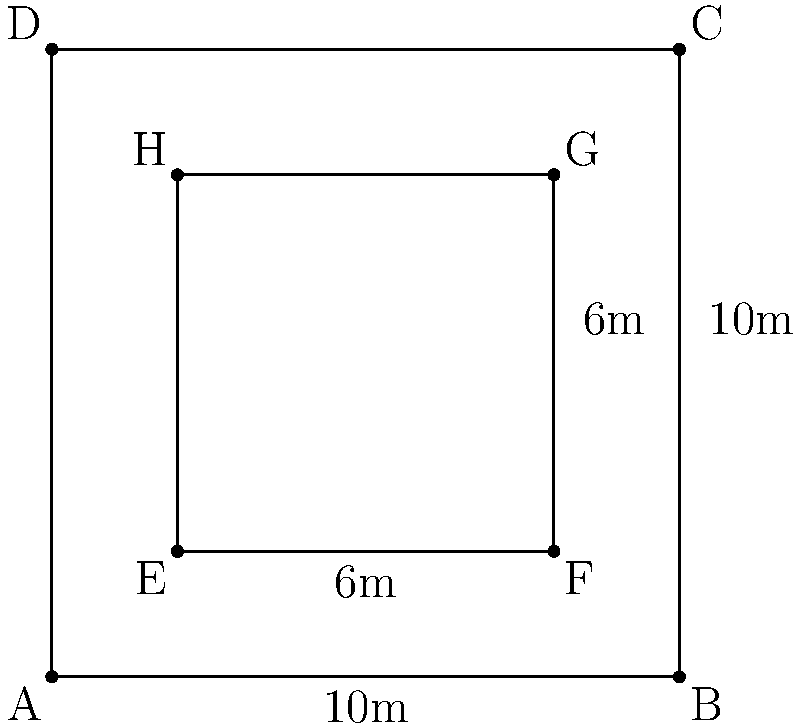A rectangular club ceiling measures 10m x 10m. You want to install an LED array that covers a 6m x 6m area in the center of the ceiling. If each LED panel is 0.5m x 0.5m, how many LED panels are needed to create the array, and what percentage of the ceiling area will be covered by the LED array? Let's approach this step-by-step:

1. Calculate the area of the LED array:
   Area of LED array = 6m × 6m = 36 m²

2. Calculate the area of each LED panel:
   Area of each panel = 0.5m × 0.5m = 0.25 m²

3. Calculate the number of LED panels needed:
   Number of panels = Area of LED array ÷ Area of each panel
   Number of panels = 36 m² ÷ 0.25 m² = 144 panels

4. Calculate the total ceiling area:
   Ceiling area = 10m × 10m = 100 m²

5. Calculate the percentage of ceiling covered by the LED array:
   Percentage covered = (Area of LED array ÷ Ceiling area) × 100
   Percentage covered = (36 m² ÷ 100 m²) × 100 = 36%

Therefore, you need 144 LED panels, and they will cover 36% of the ceiling area.
Answer: 144 panels, 36% coverage 